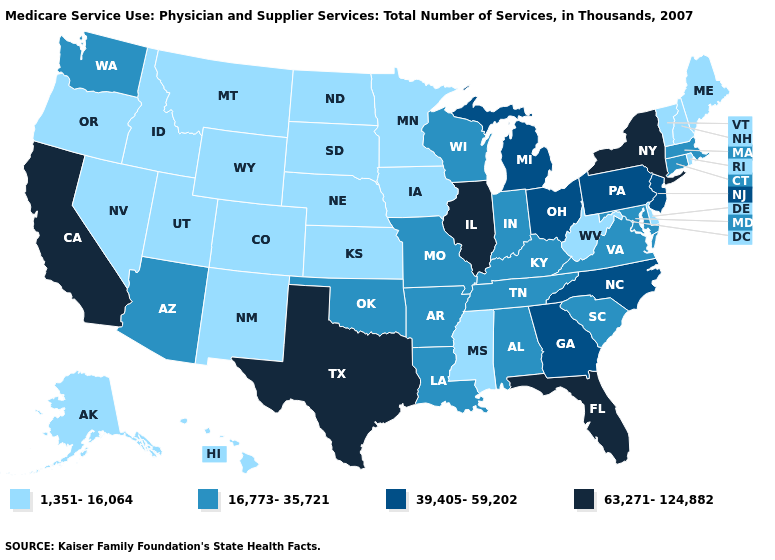What is the lowest value in states that border New Jersey?
Give a very brief answer. 1,351-16,064. Does Virginia have the same value as Vermont?
Write a very short answer. No. Does Washington have a higher value than Maine?
Quick response, please. Yes. Name the states that have a value in the range 63,271-124,882?
Short answer required. California, Florida, Illinois, New York, Texas. Name the states that have a value in the range 63,271-124,882?
Be succinct. California, Florida, Illinois, New York, Texas. Name the states that have a value in the range 63,271-124,882?
Keep it brief. California, Florida, Illinois, New York, Texas. Name the states that have a value in the range 16,773-35,721?
Answer briefly. Alabama, Arizona, Arkansas, Connecticut, Indiana, Kentucky, Louisiana, Maryland, Massachusetts, Missouri, Oklahoma, South Carolina, Tennessee, Virginia, Washington, Wisconsin. Name the states that have a value in the range 16,773-35,721?
Give a very brief answer. Alabama, Arizona, Arkansas, Connecticut, Indiana, Kentucky, Louisiana, Maryland, Massachusetts, Missouri, Oklahoma, South Carolina, Tennessee, Virginia, Washington, Wisconsin. Which states have the lowest value in the USA?
Answer briefly. Alaska, Colorado, Delaware, Hawaii, Idaho, Iowa, Kansas, Maine, Minnesota, Mississippi, Montana, Nebraska, Nevada, New Hampshire, New Mexico, North Dakota, Oregon, Rhode Island, South Dakota, Utah, Vermont, West Virginia, Wyoming. Does Ohio have a higher value than South Carolina?
Be succinct. Yes. Does Massachusetts have a lower value than New York?
Answer briefly. Yes. Is the legend a continuous bar?
Quick response, please. No. Does New York have the highest value in the Northeast?
Concise answer only. Yes. 